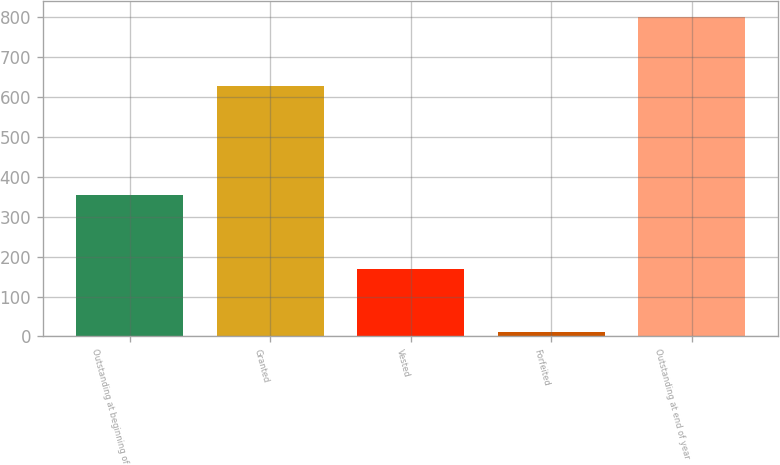Convert chart to OTSL. <chart><loc_0><loc_0><loc_500><loc_500><bar_chart><fcel>Outstanding at beginning of<fcel>Granted<fcel>Vested<fcel>Forfeited<fcel>Outstanding at end of year<nl><fcel>354<fcel>626<fcel>170<fcel>11<fcel>799<nl></chart> 